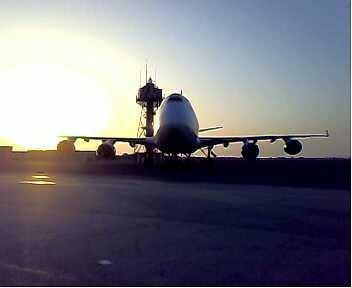How many planes are there?
Give a very brief answer. 1. 